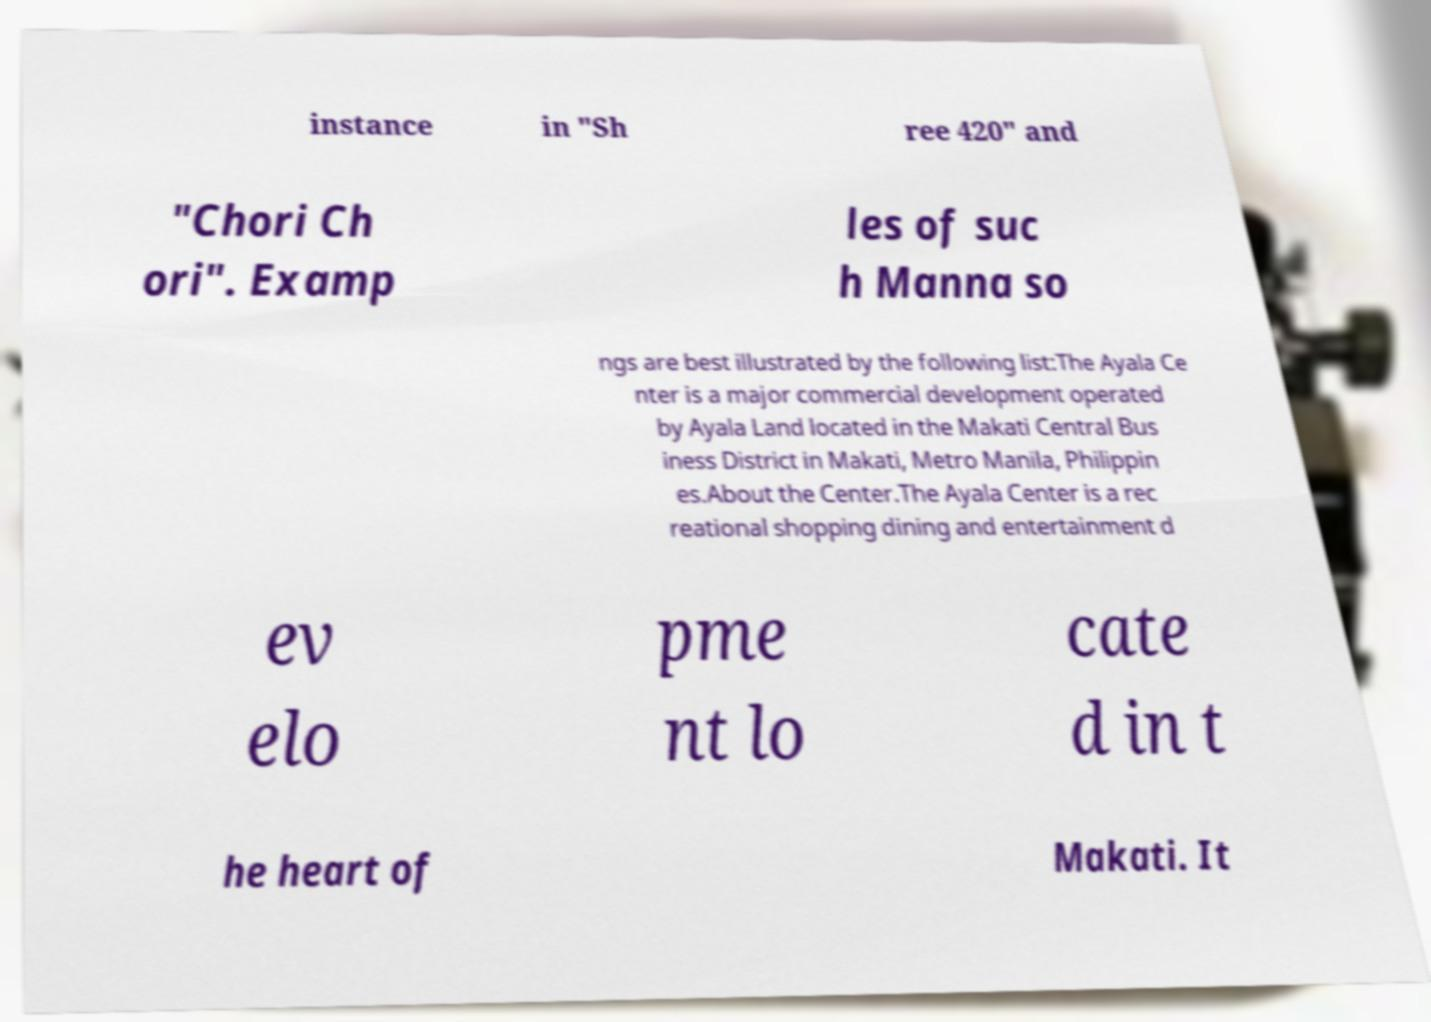Please identify and transcribe the text found in this image. instance in "Sh ree 420" and "Chori Ch ori". Examp les of suc h Manna so ngs are best illustrated by the following list:The Ayala Ce nter is a major commercial development operated by Ayala Land located in the Makati Central Bus iness District in Makati, Metro Manila, Philippin es.About the Center.The Ayala Center is a rec reational shopping dining and entertainment d ev elo pme nt lo cate d in t he heart of Makati. It 